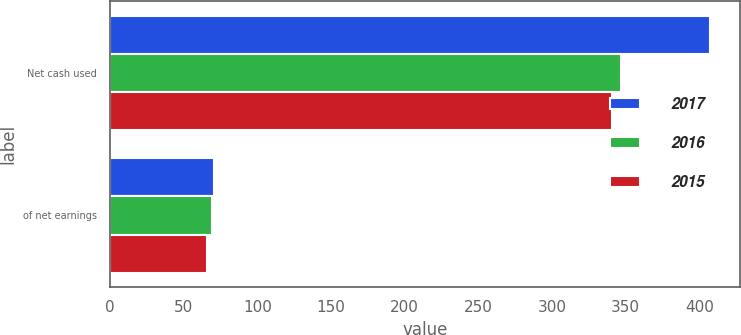Convert chart. <chart><loc_0><loc_0><loc_500><loc_500><stacked_bar_chart><ecel><fcel>Net cash used<fcel>of net earnings<nl><fcel>2017<fcel>407.2<fcel>70.4<nl><fcel>2016<fcel>346.8<fcel>69.4<nl><fcel>2015<fcel>340.9<fcel>66<nl></chart> 